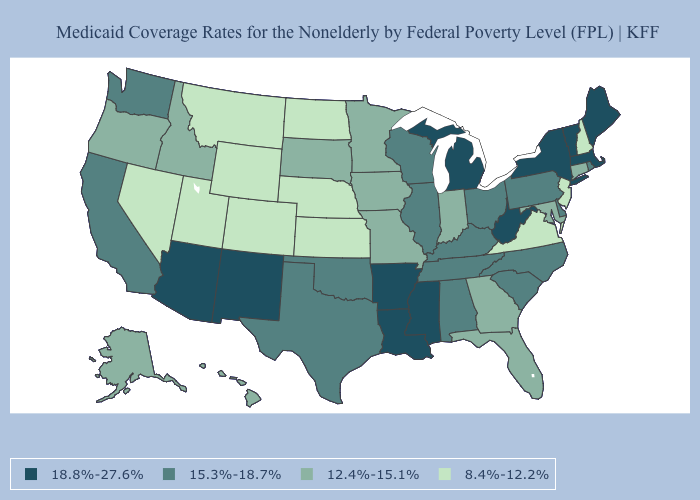Name the states that have a value in the range 15.3%-18.7%?
Quick response, please. Alabama, California, Delaware, Illinois, Kentucky, North Carolina, Ohio, Oklahoma, Pennsylvania, Rhode Island, South Carolina, Tennessee, Texas, Washington, Wisconsin. Which states have the highest value in the USA?
Give a very brief answer. Arizona, Arkansas, Louisiana, Maine, Massachusetts, Michigan, Mississippi, New Mexico, New York, Vermont, West Virginia. Does Arkansas have the highest value in the USA?
Be succinct. Yes. Does the first symbol in the legend represent the smallest category?
Answer briefly. No. What is the value of Maine?
Be succinct. 18.8%-27.6%. Among the states that border Wisconsin , does Michigan have the highest value?
Write a very short answer. Yes. What is the value of West Virginia?
Write a very short answer. 18.8%-27.6%. Does Pennsylvania have the lowest value in the Northeast?
Answer briefly. No. What is the lowest value in the USA?
Keep it brief. 8.4%-12.2%. What is the lowest value in the South?
Write a very short answer. 8.4%-12.2%. Name the states that have a value in the range 15.3%-18.7%?
Keep it brief. Alabama, California, Delaware, Illinois, Kentucky, North Carolina, Ohio, Oklahoma, Pennsylvania, Rhode Island, South Carolina, Tennessee, Texas, Washington, Wisconsin. What is the lowest value in states that border Arkansas?
Short answer required. 12.4%-15.1%. Among the states that border Tennessee , does Alabama have the lowest value?
Answer briefly. No. Which states hav the highest value in the MidWest?
Answer briefly. Michigan. Does Maine have a higher value than California?
Keep it brief. Yes. 